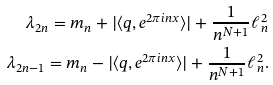<formula> <loc_0><loc_0><loc_500><loc_500>\lambda _ { 2 n } = m _ { n } + | \langle q , e ^ { 2 \pi i n x } \rangle | + \frac { 1 } { n ^ { N + 1 } } \ell ^ { 2 } _ { n } \\ \lambda _ { 2 n - 1 } = m _ { n } - | \langle q , e ^ { 2 \pi i n x } \rangle | + \frac { 1 } { n ^ { N + 1 } } \ell ^ { 2 } _ { n } .</formula> 